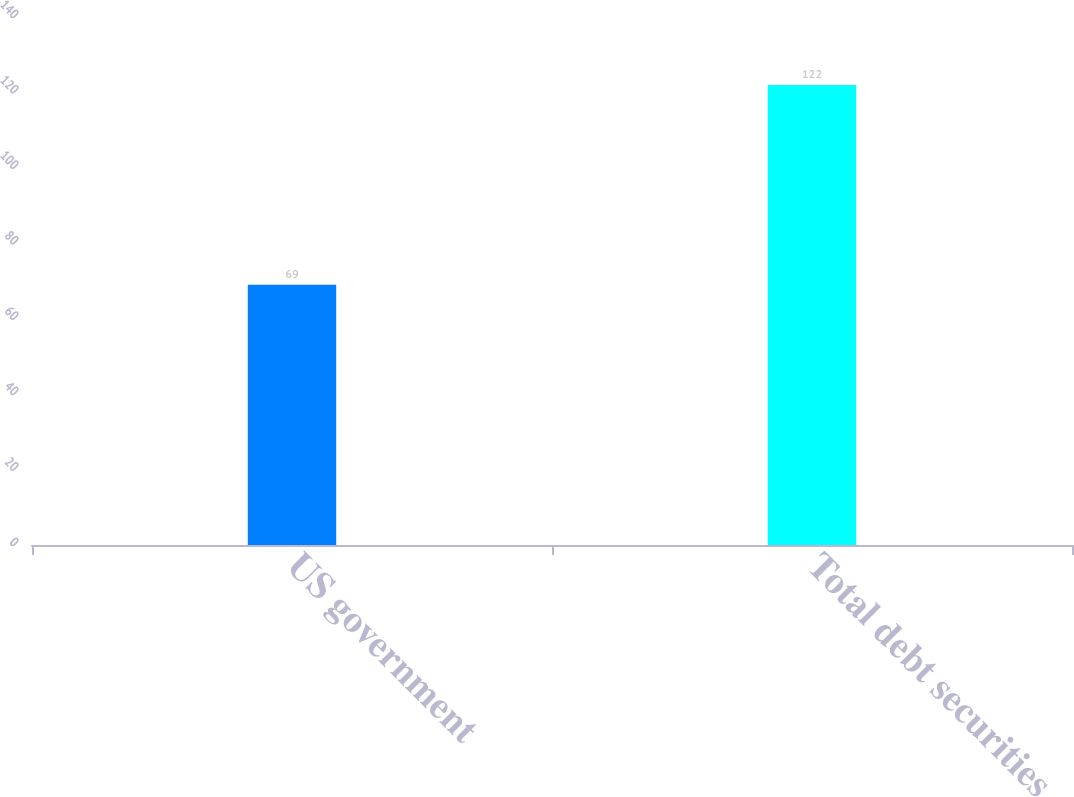<chart> <loc_0><loc_0><loc_500><loc_500><bar_chart><fcel>US government<fcel>Total debt securities<nl><fcel>69<fcel>122<nl></chart> 